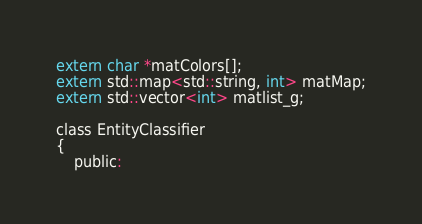<code> <loc_0><loc_0><loc_500><loc_500><_C_>extern char *matColors[];
extern std::map<std::string, int> matMap;
extern std::vector<int> matlist_g;

class EntityClassifier
{
    public:</code> 